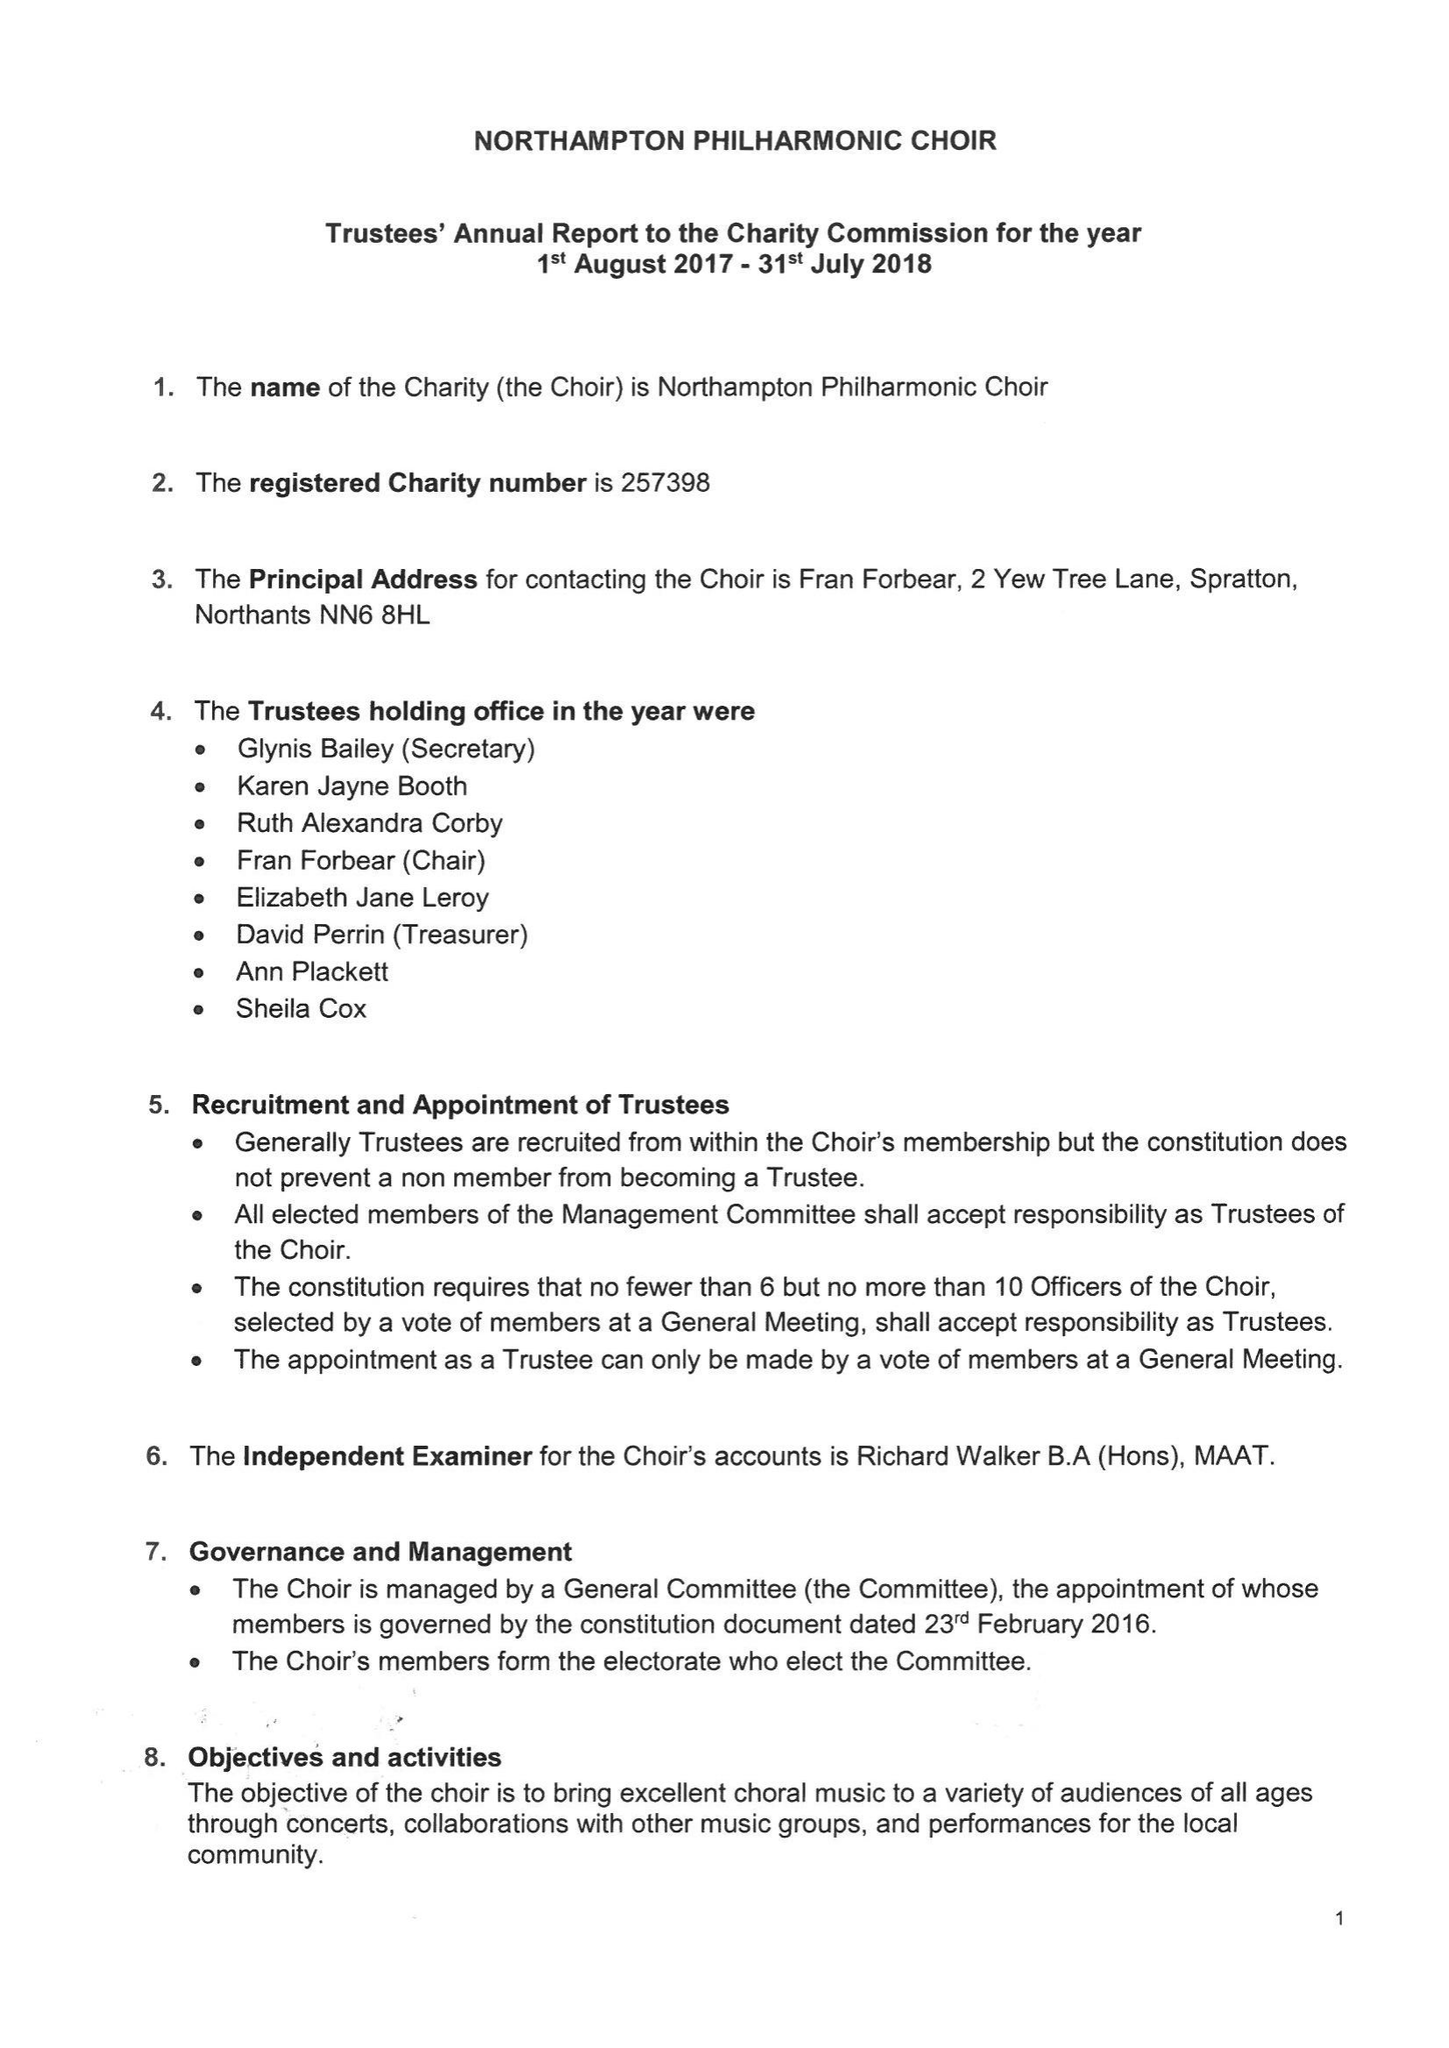What is the value for the charity_name?
Answer the question using a single word or phrase. Northampton Philharmonic Choir 